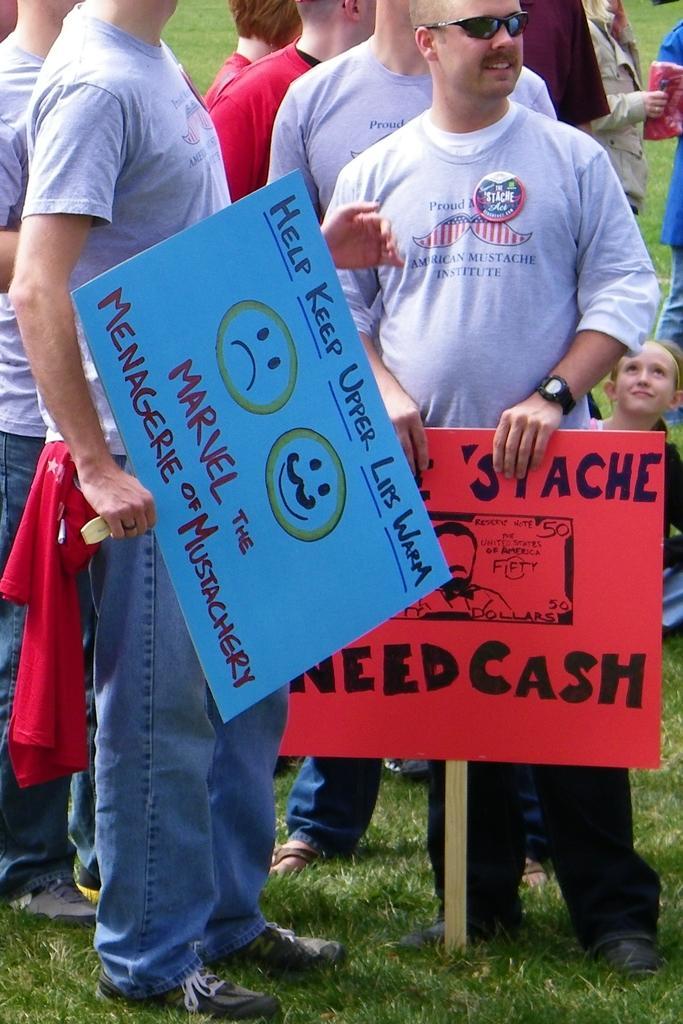Please provide a concise description of this image. In this image we can see people standing on the ground and holding placards in their hands. In the background we can see a woman sitting on the ground. 